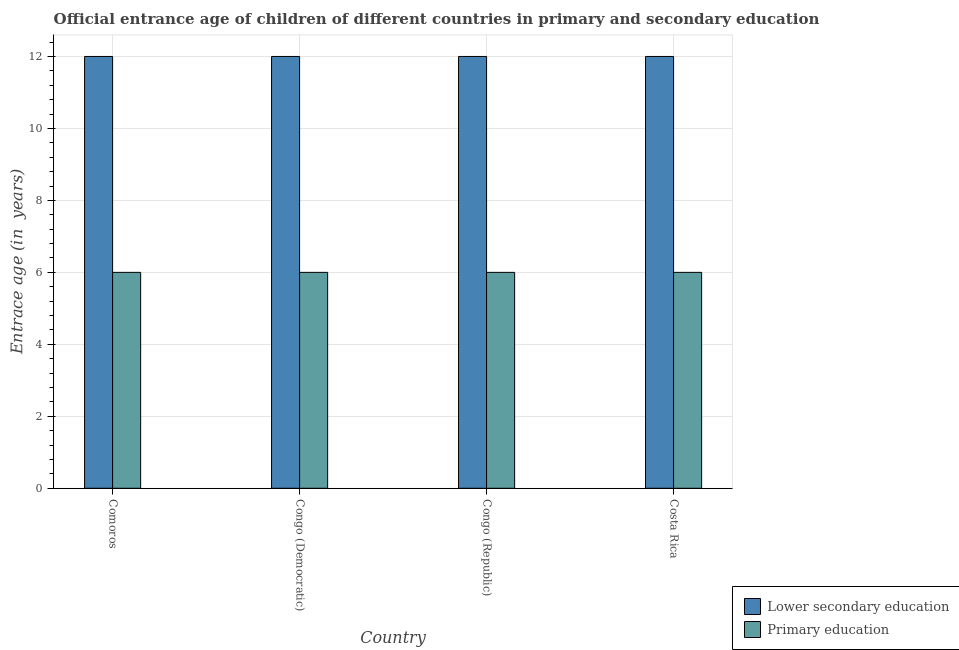Are the number of bars on each tick of the X-axis equal?
Your answer should be very brief. Yes. What is the label of the 1st group of bars from the left?
Offer a terse response. Comoros. What is the entrance age of children in lower secondary education in Comoros?
Your answer should be very brief. 12. Across all countries, what is the maximum entrance age of children in lower secondary education?
Offer a very short reply. 12. Across all countries, what is the minimum entrance age of children in lower secondary education?
Offer a very short reply. 12. In which country was the entrance age of chiildren in primary education maximum?
Make the answer very short. Comoros. In which country was the entrance age of children in lower secondary education minimum?
Provide a short and direct response. Comoros. What is the total entrance age of chiildren in primary education in the graph?
Ensure brevity in your answer.  24. What is the difference between the entrance age of chiildren in primary education in Comoros and the entrance age of children in lower secondary education in Costa Rica?
Keep it short and to the point. -6. What is the difference between the entrance age of chiildren in primary education and entrance age of children in lower secondary education in Congo (Republic)?
Your answer should be very brief. -6. What is the ratio of the entrance age of children in lower secondary education in Congo (Democratic) to that in Congo (Republic)?
Your answer should be compact. 1. Is the difference between the entrance age of chiildren in primary education in Congo (Democratic) and Congo (Republic) greater than the difference between the entrance age of children in lower secondary education in Congo (Democratic) and Congo (Republic)?
Give a very brief answer. No. Is the sum of the entrance age of chiildren in primary education in Comoros and Costa Rica greater than the maximum entrance age of children in lower secondary education across all countries?
Make the answer very short. No. What does the 2nd bar from the left in Congo (Democratic) represents?
Offer a very short reply. Primary education. What does the 2nd bar from the right in Congo (Republic) represents?
Keep it short and to the point. Lower secondary education. Are all the bars in the graph horizontal?
Make the answer very short. No. How many countries are there in the graph?
Provide a short and direct response. 4. What is the difference between two consecutive major ticks on the Y-axis?
Provide a short and direct response. 2. How are the legend labels stacked?
Make the answer very short. Vertical. What is the title of the graph?
Provide a short and direct response. Official entrance age of children of different countries in primary and secondary education. Does "Research and Development" appear as one of the legend labels in the graph?
Keep it short and to the point. No. What is the label or title of the X-axis?
Provide a succinct answer. Country. What is the label or title of the Y-axis?
Your response must be concise. Entrace age (in  years). What is the Entrace age (in  years) of Lower secondary education in Comoros?
Provide a short and direct response. 12. What is the Entrace age (in  years) of Lower secondary education in Congo (Democratic)?
Give a very brief answer. 12. What is the Entrace age (in  years) of Primary education in Congo (Democratic)?
Provide a succinct answer. 6. What is the Entrace age (in  years) of Lower secondary education in Congo (Republic)?
Provide a succinct answer. 12. What is the Entrace age (in  years) in Primary education in Costa Rica?
Offer a very short reply. 6. Across all countries, what is the maximum Entrace age (in  years) of Lower secondary education?
Give a very brief answer. 12. Across all countries, what is the minimum Entrace age (in  years) in Primary education?
Offer a very short reply. 6. What is the difference between the Entrace age (in  years) in Lower secondary education in Comoros and that in Congo (Democratic)?
Make the answer very short. 0. What is the difference between the Entrace age (in  years) in Primary education in Comoros and that in Costa Rica?
Provide a succinct answer. 0. What is the difference between the Entrace age (in  years) of Lower secondary education in Congo (Democratic) and that in Congo (Republic)?
Provide a short and direct response. 0. What is the difference between the Entrace age (in  years) in Primary education in Congo (Democratic) and that in Congo (Republic)?
Your answer should be compact. 0. What is the difference between the Entrace age (in  years) in Lower secondary education in Congo (Democratic) and that in Costa Rica?
Make the answer very short. 0. What is the difference between the Entrace age (in  years) of Primary education in Congo (Democratic) and that in Costa Rica?
Offer a terse response. 0. What is the difference between the Entrace age (in  years) in Lower secondary education in Congo (Republic) and that in Costa Rica?
Provide a succinct answer. 0. What is the difference between the Entrace age (in  years) of Lower secondary education in Comoros and the Entrace age (in  years) of Primary education in Costa Rica?
Your response must be concise. 6. What is the difference between the Entrace age (in  years) of Lower secondary education in Congo (Democratic) and the Entrace age (in  years) of Primary education in Costa Rica?
Keep it short and to the point. 6. What is the average Entrace age (in  years) in Lower secondary education per country?
Give a very brief answer. 12. What is the difference between the Entrace age (in  years) of Lower secondary education and Entrace age (in  years) of Primary education in Comoros?
Make the answer very short. 6. What is the difference between the Entrace age (in  years) of Lower secondary education and Entrace age (in  years) of Primary education in Congo (Democratic)?
Your response must be concise. 6. What is the difference between the Entrace age (in  years) in Lower secondary education and Entrace age (in  years) in Primary education in Congo (Republic)?
Your answer should be very brief. 6. What is the difference between the Entrace age (in  years) of Lower secondary education and Entrace age (in  years) of Primary education in Costa Rica?
Your answer should be very brief. 6. What is the ratio of the Entrace age (in  years) in Primary education in Comoros to that in Congo (Democratic)?
Offer a terse response. 1. What is the ratio of the Entrace age (in  years) of Lower secondary education in Comoros to that in Congo (Republic)?
Make the answer very short. 1. What is the ratio of the Entrace age (in  years) in Lower secondary education in Comoros to that in Costa Rica?
Offer a very short reply. 1. What is the ratio of the Entrace age (in  years) in Primary education in Comoros to that in Costa Rica?
Offer a terse response. 1. What is the ratio of the Entrace age (in  years) of Primary education in Congo (Democratic) to that in Congo (Republic)?
Your answer should be compact. 1. What is the ratio of the Entrace age (in  years) in Primary education in Congo (Republic) to that in Costa Rica?
Provide a succinct answer. 1. What is the difference between the highest and the second highest Entrace age (in  years) of Lower secondary education?
Give a very brief answer. 0. What is the difference between the highest and the second highest Entrace age (in  years) in Primary education?
Ensure brevity in your answer.  0. What is the difference between the highest and the lowest Entrace age (in  years) of Lower secondary education?
Provide a short and direct response. 0. 